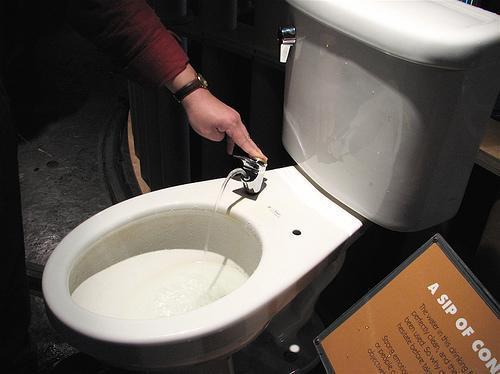How many people at the table are wearing tie dye?
Give a very brief answer. 0. 